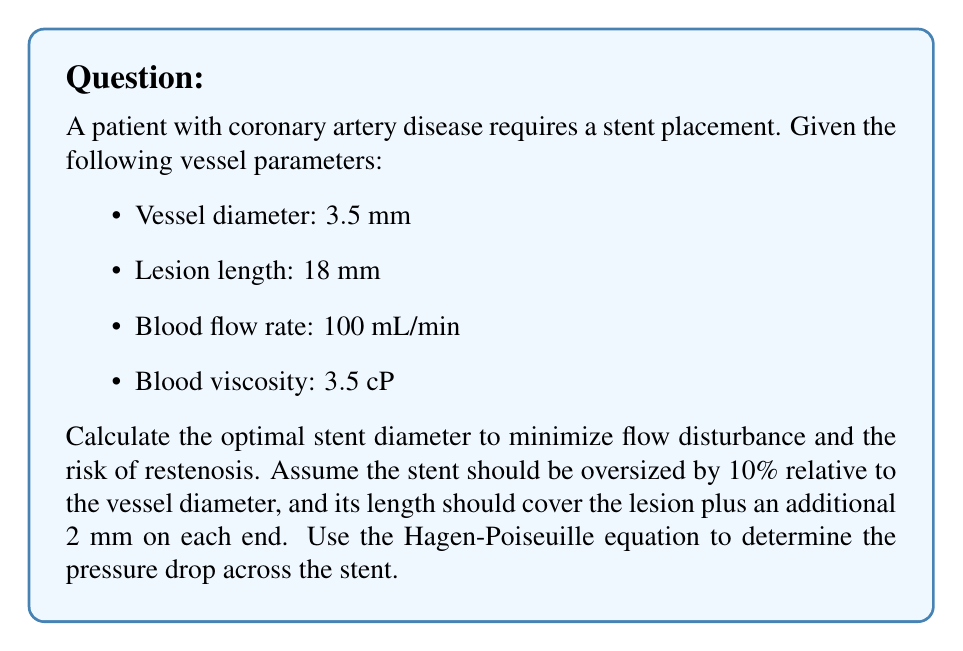Could you help me with this problem? 1. Calculate the optimal stent diameter:
   Stent diameter = Vessel diameter × 1.10
   $D_{stent} = 3.5 \text{ mm} \times 1.10 = 3.85 \text{ mm}$

2. Calculate the optimal stent length:
   Stent length = Lesion length + 2 mm + 2 mm
   $L_{stent} = 18 \text{ mm} + 4 \text{ mm} = 22 \text{ mm}$

3. Convert units for the Hagen-Poiseuille equation:
   - Diameter: $D = 3.85 \text{ mm} = 3.85 \times 10^{-3} \text{ m}$
   - Length: $L = 22 \text{ mm} = 22 \times 10^{-3} \text{ m}$
   - Flow rate: $Q = 100 \text{ mL/min} = 1.667 \times 10^{-6} \text{ m}^3/\text{s}$
   - Viscosity: $\mu = 3.5 \text{ cP} = 3.5 \times 10^{-3} \text{ Pa}\cdot\text{s}$

4. Apply the Hagen-Poiseuille equation to calculate the pressure drop:
   $$\Delta P = \frac{128\mu LQ}{\pi D^4}$$

   $$\Delta P = \frac{128 \times (3.5 \times 10^{-3}) \times (22 \times 10^{-3}) \times (1.667 \times 10^{-6})}{\pi \times (3.85 \times 10^{-3})^4}$$

   $$\Delta P = 79.2 \text{ Pa} = 0.594 \text{ mmHg}$$

The calculated pressure drop is relatively low, indicating that the chosen stent dimensions should not significantly disrupt blood flow.
Answer: Optimal stent dimensions: diameter = 3.85 mm, length = 22 mm 